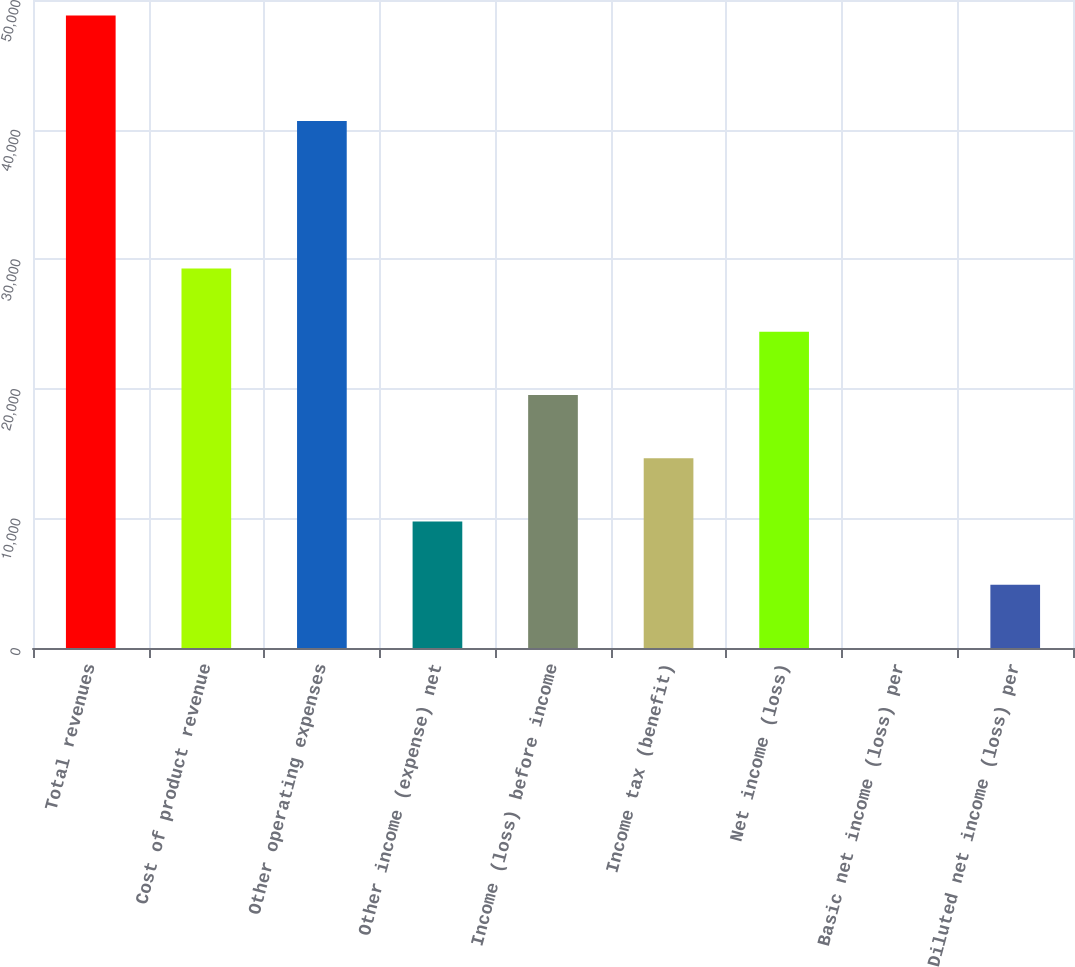<chart> <loc_0><loc_0><loc_500><loc_500><bar_chart><fcel>Total revenues<fcel>Cost of product revenue<fcel>Other operating expenses<fcel>Other income (expense) net<fcel>Income (loss) before income<fcel>Income tax (benefit)<fcel>Net income (loss)<fcel>Basic net income (loss) per<fcel>Diluted net income (loss) per<nl><fcel>48811<fcel>29286.6<fcel>40660<fcel>9762.24<fcel>19524.4<fcel>14643.3<fcel>24405.5<fcel>0.04<fcel>4881.14<nl></chart> 